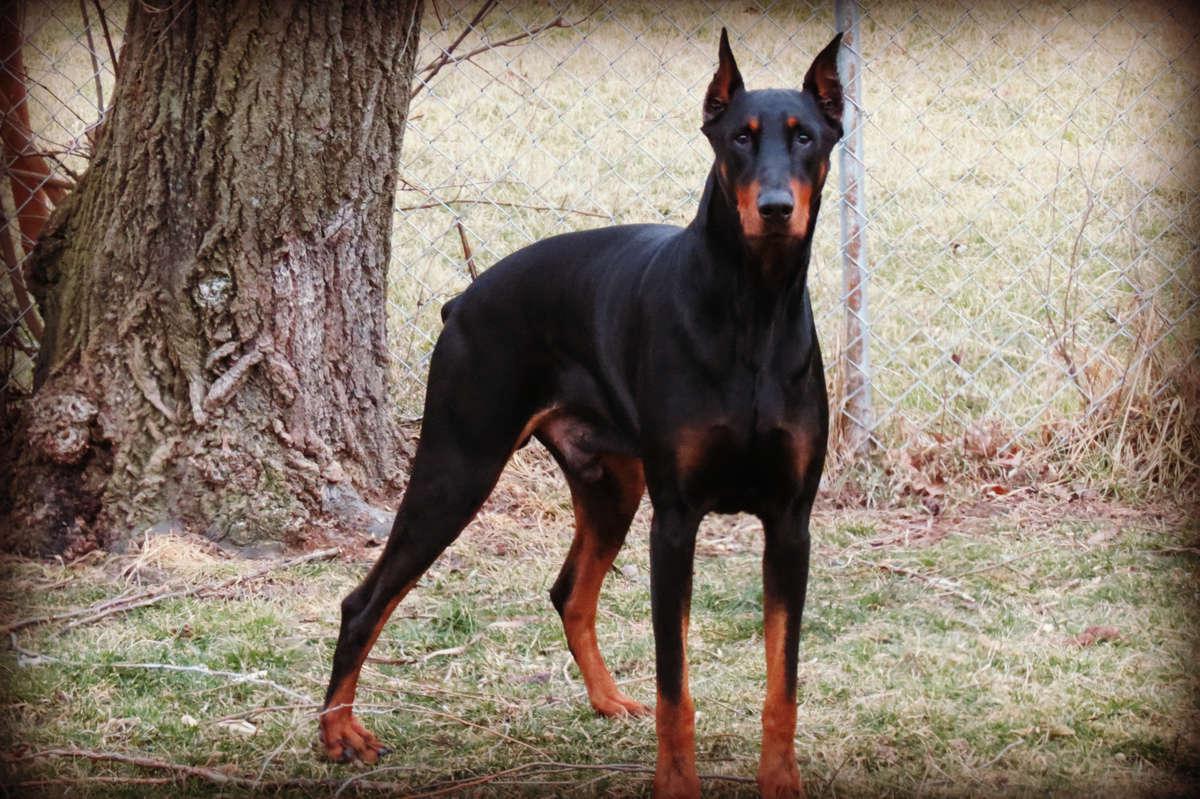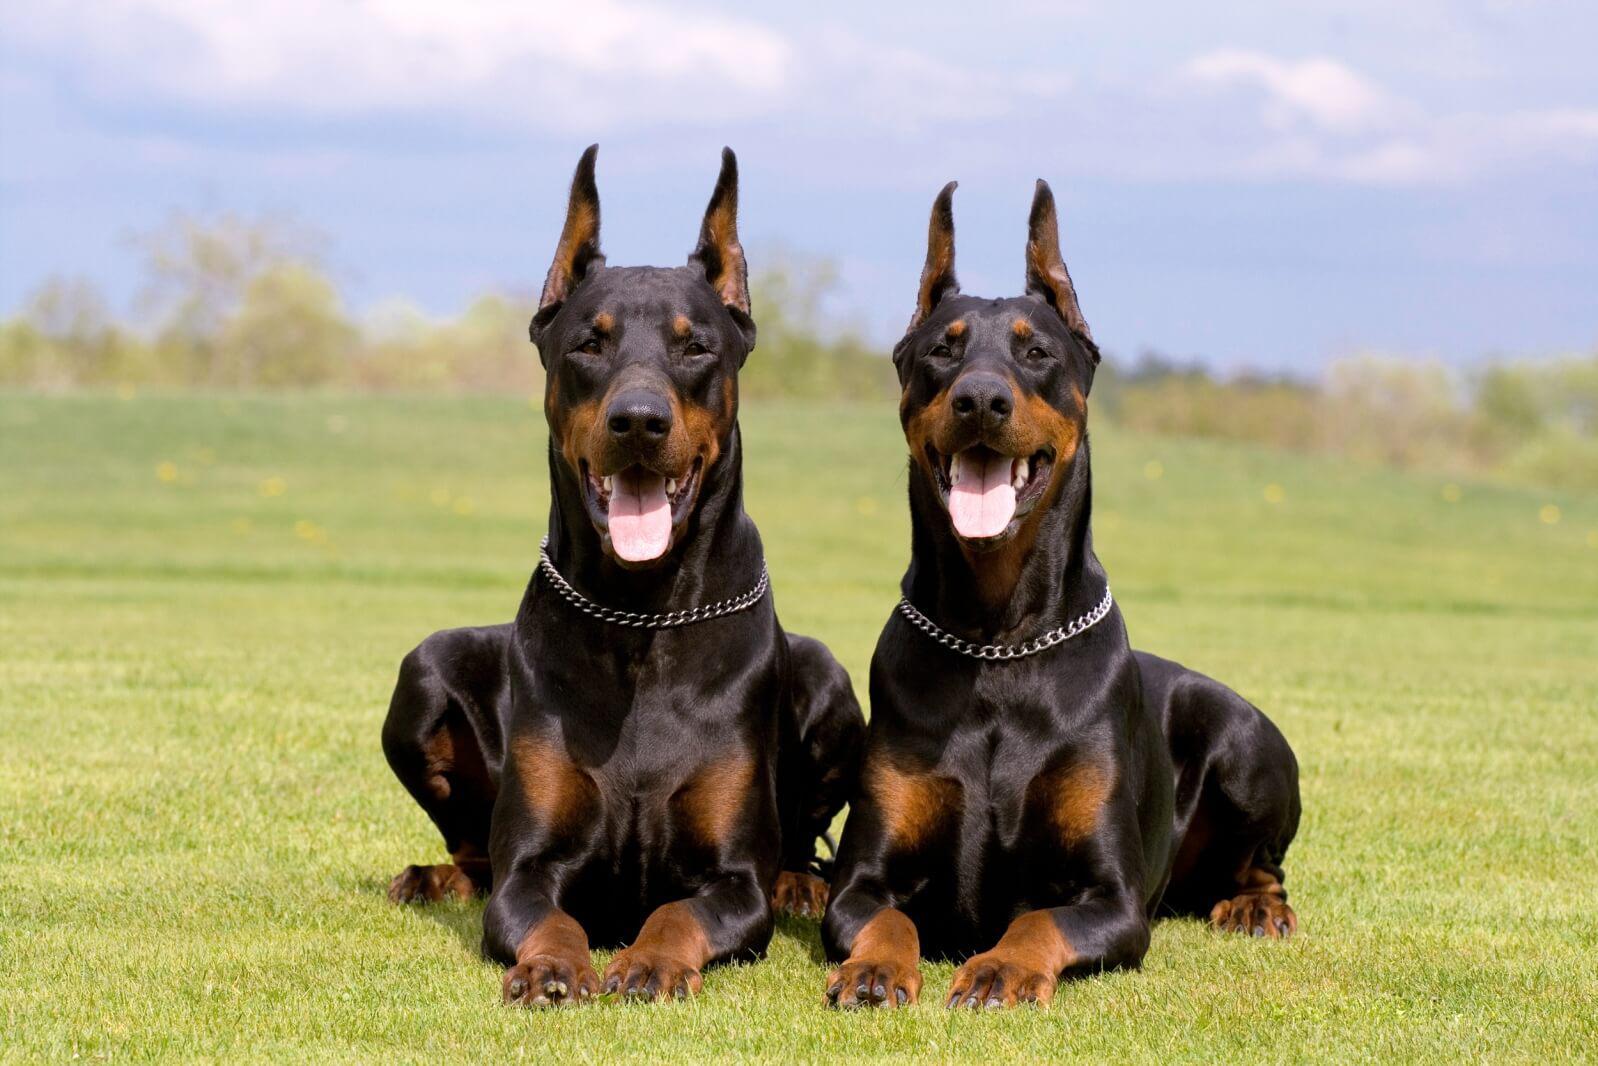The first image is the image on the left, the second image is the image on the right. For the images displayed, is the sentence "there is a doberman with a taught leash attached to it's collar" factually correct? Answer yes or no. No. The first image is the image on the left, the second image is the image on the right. Given the left and right images, does the statement "Each image contains one doberman with erect ears, and the left image features a doberman standing with its head and body angled leftward." hold true? Answer yes or no. No. 